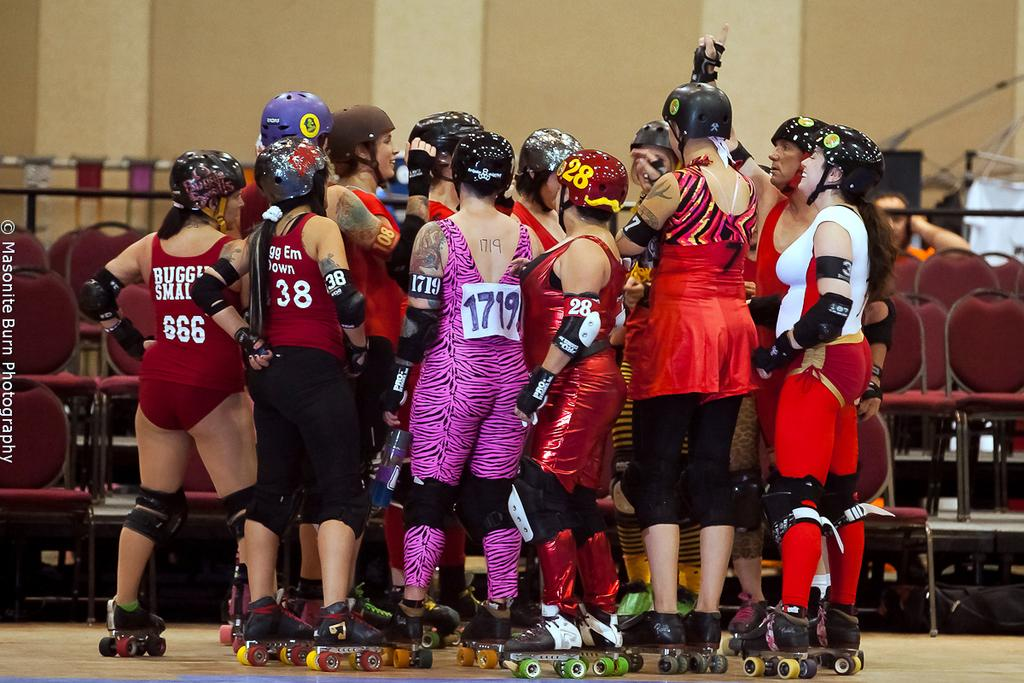<image>
Relay a brief, clear account of the picture shown. A colourful mob of roller bladers wear the numbers 666, 38 and 1719 amongst others. 